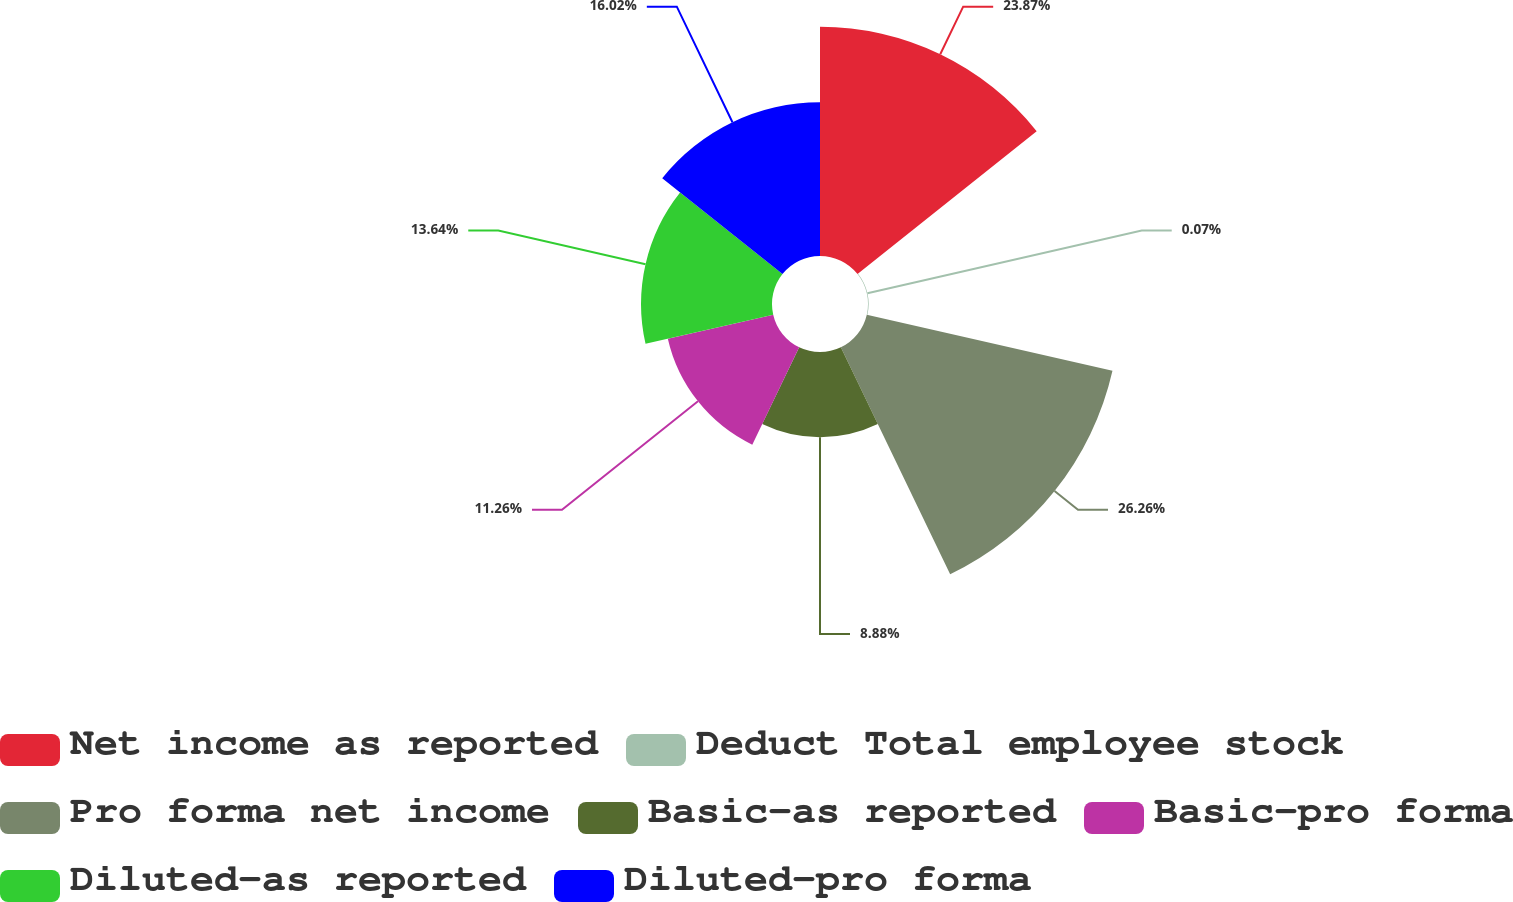<chart> <loc_0><loc_0><loc_500><loc_500><pie_chart><fcel>Net income as reported<fcel>Deduct Total employee stock<fcel>Pro forma net income<fcel>Basic-as reported<fcel>Basic-pro forma<fcel>Diluted-as reported<fcel>Diluted-pro forma<nl><fcel>23.87%<fcel>0.07%<fcel>26.25%<fcel>8.88%<fcel>11.26%<fcel>13.64%<fcel>16.02%<nl></chart> 